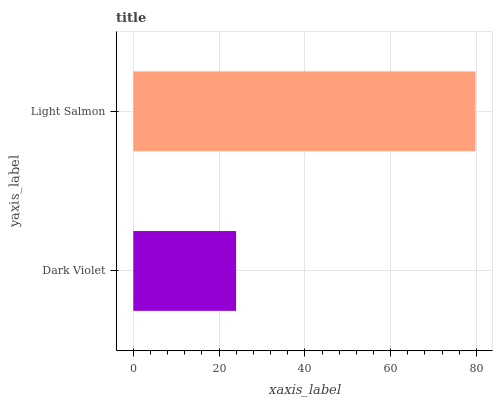Is Dark Violet the minimum?
Answer yes or no. Yes. Is Light Salmon the maximum?
Answer yes or no. Yes. Is Light Salmon the minimum?
Answer yes or no. No. Is Light Salmon greater than Dark Violet?
Answer yes or no. Yes. Is Dark Violet less than Light Salmon?
Answer yes or no. Yes. Is Dark Violet greater than Light Salmon?
Answer yes or no. No. Is Light Salmon less than Dark Violet?
Answer yes or no. No. Is Light Salmon the high median?
Answer yes or no. Yes. Is Dark Violet the low median?
Answer yes or no. Yes. Is Dark Violet the high median?
Answer yes or no. No. Is Light Salmon the low median?
Answer yes or no. No. 